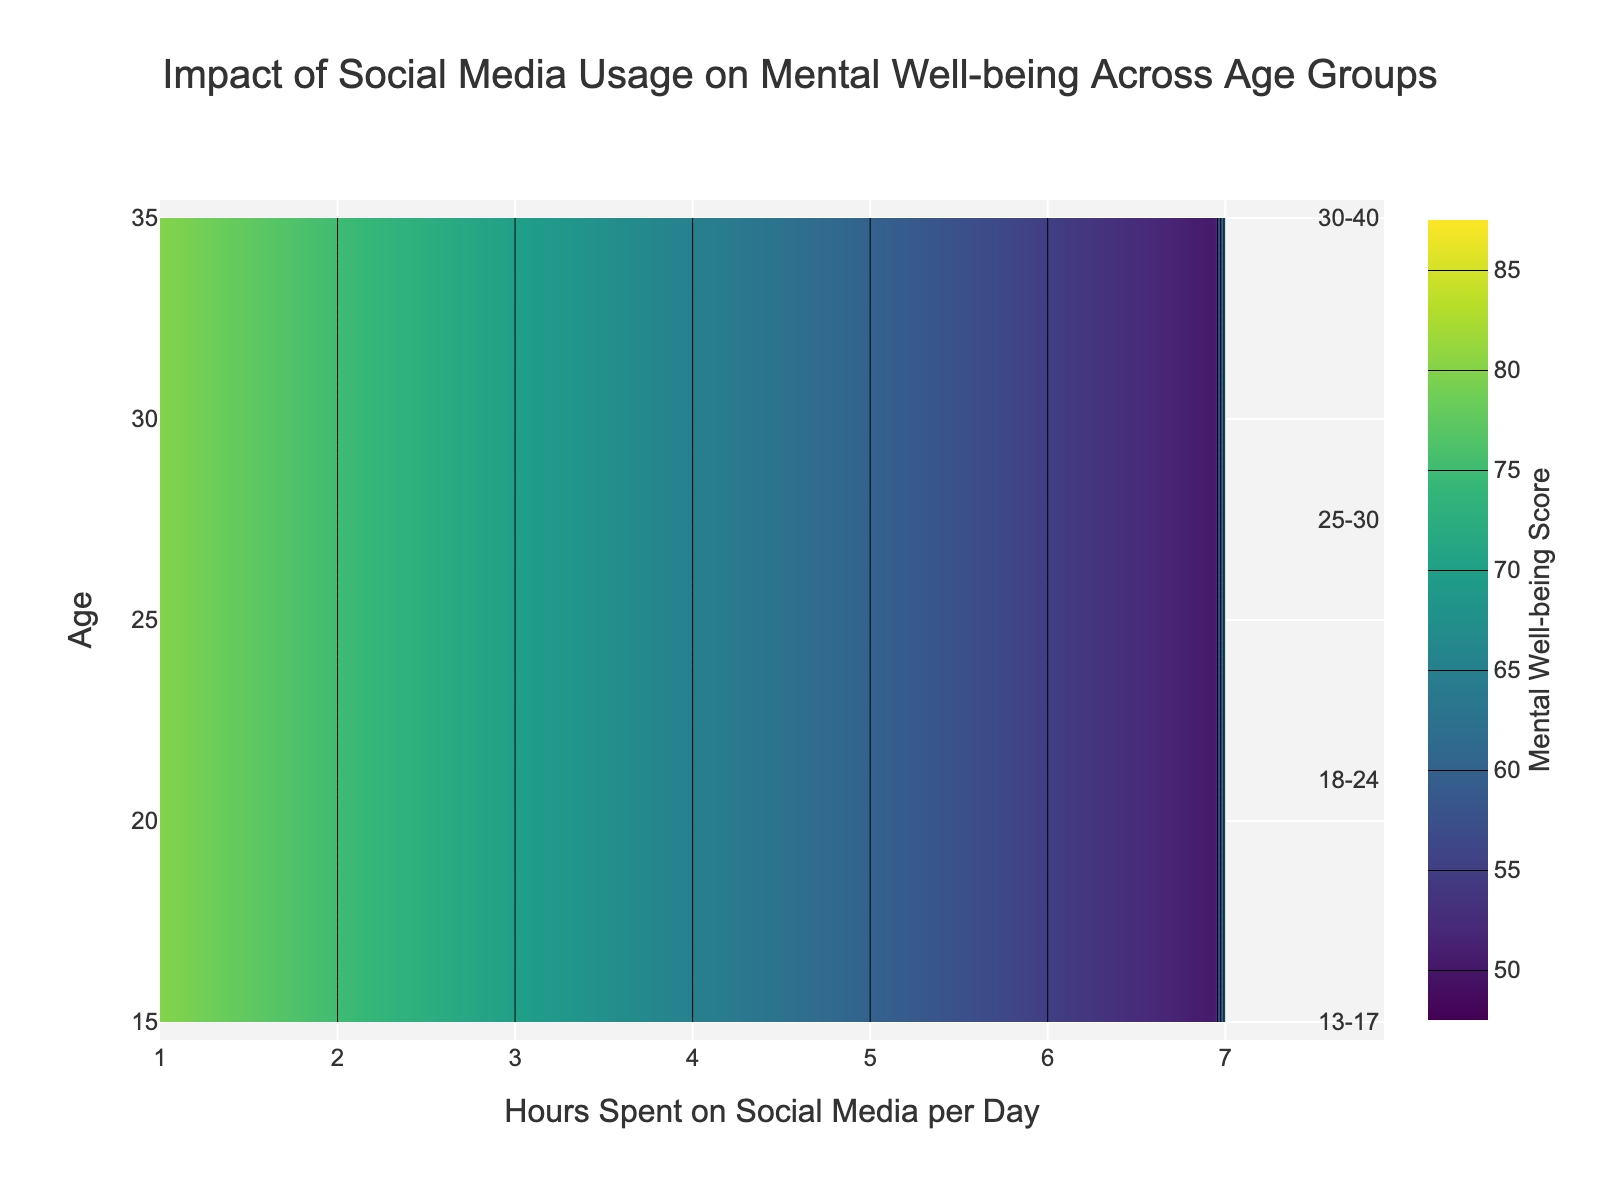What is the title of the figure? The title is usually located at the top center of the figure, and it describes what the figure is about. By reading the title, we can summarize that the figure displays the "Impact of Social Media Usage on Mental Well-being Across Age Groups".
Answer: Impact of Social Media Usage on Mental Well-being Across Age Groups What is the color scale used in the figure? The color scale represents different values in the contour plot. From the figure, the color scale used is 'Viridis', which typically transitions from dark blue to yellow, indicating the range of mental well-being scores.
Answer: Viridis What is the mental well-being score for teens (13-17) who spend 4 hours on social media? To find this, locate the contour line that corresponds to 4 hours on the x-axis and view where it intersects with the contour level for the age group 13-17. According to the color gradient and annotations, the mental well-being score is at 65.
Answer: 65 How does the mental well-being score change for adults aged 30-40 as they spend more hours on social media? For this, examine the contours starting at 1 hour and observing the score's progression as you move to the right on the x-axis. The score starts at 85 and continuously decreases, showing that the score drops as hours increase.
Answer: Decreases Which age group has the highest mental well-being score with 1 hour of social media usage? Observe the y-axis at the 1-hour mark and find the corresponding mental well-being scores across different contours. The highest value appears at the age group 30-40, where the value is 85.
Answer: 30-40 By how much does the mental well-being score of the 18-24 age group decrease from 1 hour to 7 hours of social media usage? Identify the scores for 18-24 at 1 hour (78) and 7 hours (55). Subtract the smaller value from the larger value to compute the decrease. Therefore, 78 - 55 = 23.
Answer: 23 Between which age groups does the mental well-being exhibit the most significant drop when social media usage increases from 2 hours to 6 hours per day? To determine this, compare the differences in mental well-being scores between 2 hours and 6 hours for each group. The 13-17 age group has the most considerable drop, from 75 to 55, resulting in a 20-point decrease.
Answer: 13-17 Compare the effect of 3 hours of social media usage on the mental well-being scores of the 25-30 and 30-40 age groups. Which age group has a better score? Identify the scores for 3 hours at respective age groups. For the 25-30 group, it is 74, and for 30-40, it is 79. The 30-40 age group has the better score.
Answer: 30-40 What is the pattern in the scores across all age groups as the daily hours on social media increase from 1 hour to 7 hours? Examine the scores along the x-axis from 1 to 7 hours. For all age groups, the mental well-being scores show a downward trend, signifying a decline as social media usage increases.
Answer: Downward trend Is there any age group whose mental well-being score remains almost stable regardless of social media usage hours? Look at each age group’s contour lines to see if there's minimal change in score. Each age group’s score decreases, so none remain stable across different usage hours.
Answer: No 